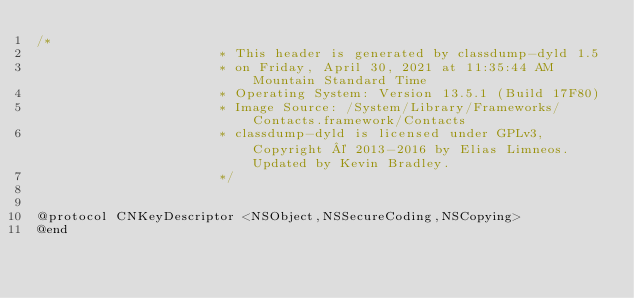Convert code to text. <code><loc_0><loc_0><loc_500><loc_500><_C_>/*
                       * This header is generated by classdump-dyld 1.5
                       * on Friday, April 30, 2021 at 11:35:44 AM Mountain Standard Time
                       * Operating System: Version 13.5.1 (Build 17F80)
                       * Image Source: /System/Library/Frameworks/Contacts.framework/Contacts
                       * classdump-dyld is licensed under GPLv3, Copyright © 2013-2016 by Elias Limneos. Updated by Kevin Bradley.
                       */


@protocol CNKeyDescriptor <NSObject,NSSecureCoding,NSCopying>
@end

</code> 